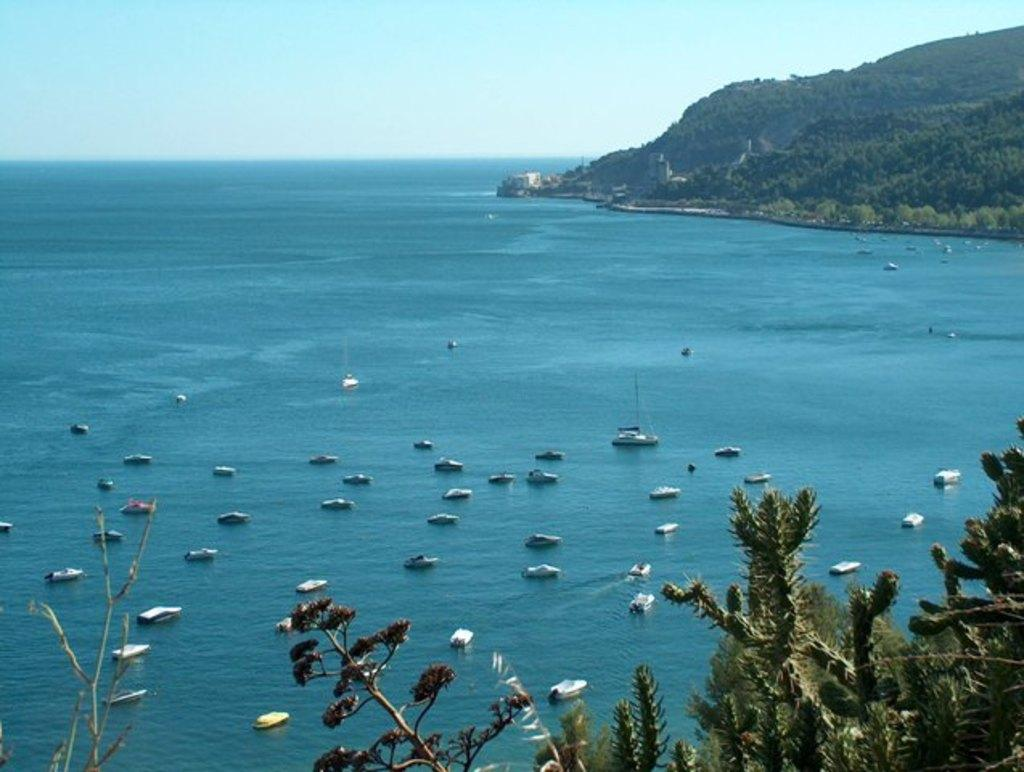What is in the water in the image? There are boats in the water in the image. What can be seen on the right side of the image? There are hills and trees on the right side of the image. What is visible in the background of the image? The sky is visible in the background of the image. What type of patch is being sewn onto the boat in the image? There is no patch or sewing activity depicted in the image; it features boats in the water, hills, trees, and the sky. What kind of bomb can be seen in the image? There is no bomb present in the image. 